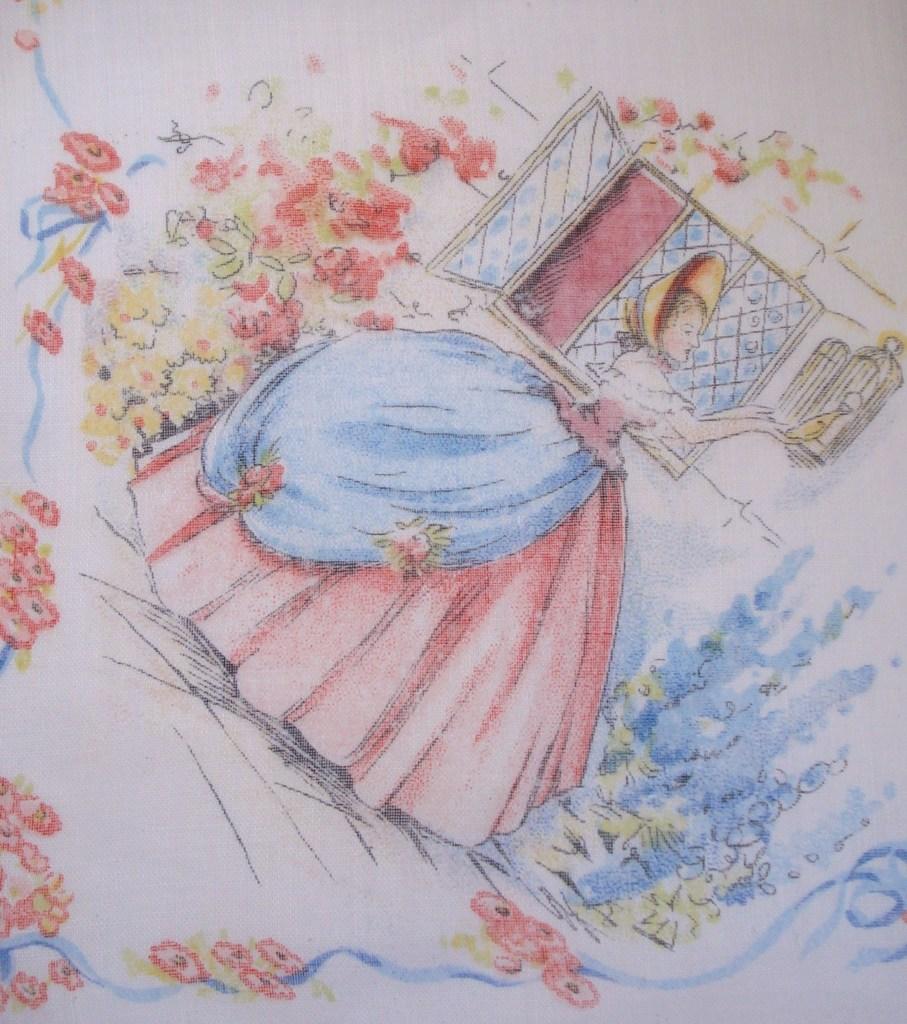How would you summarize this image in a sentence or two? In this image we can see a drawing with different colors on the paper. In this drawing there is a person, window and flowers. 